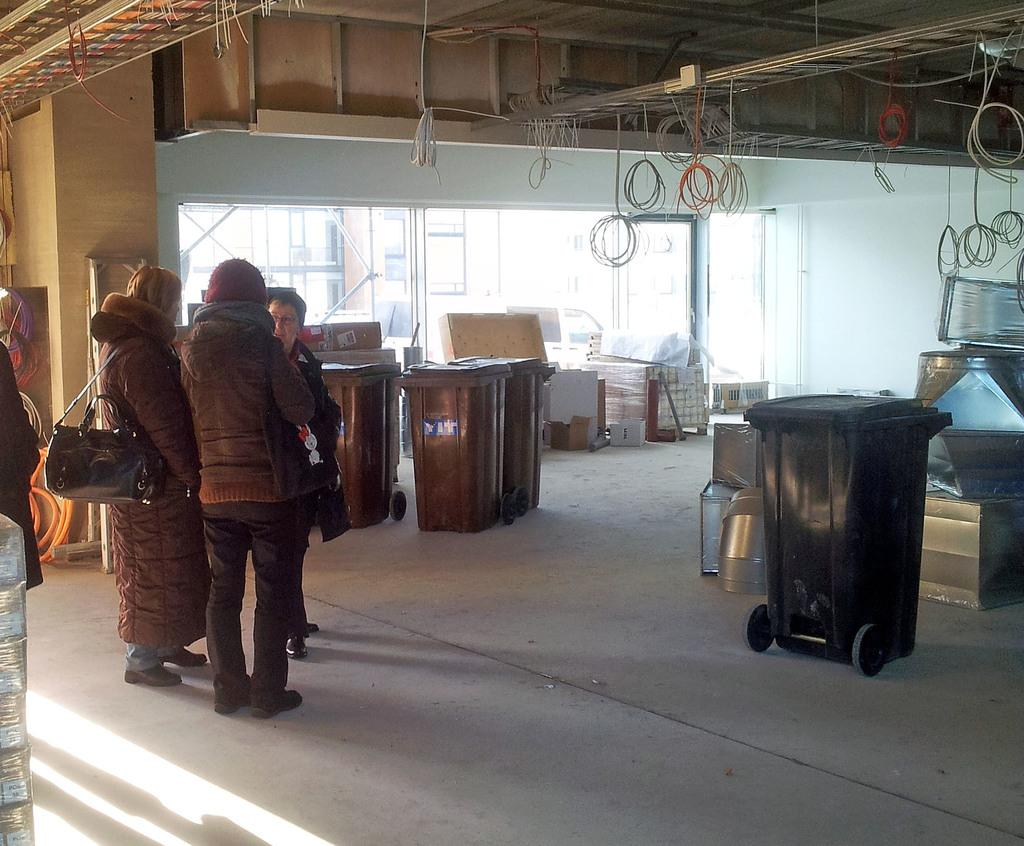Who or what can be seen on the left side of the image? There are people on the left side of the image. What objects are present in the image besides the people? There are boxes in the image. What can be seen hanging at the top of the image? There are wires hanging on a rod at the top of the image. Can you hear the snake hissing in the image? There is no snake present in the image, so it is not possible to hear any hissing. 